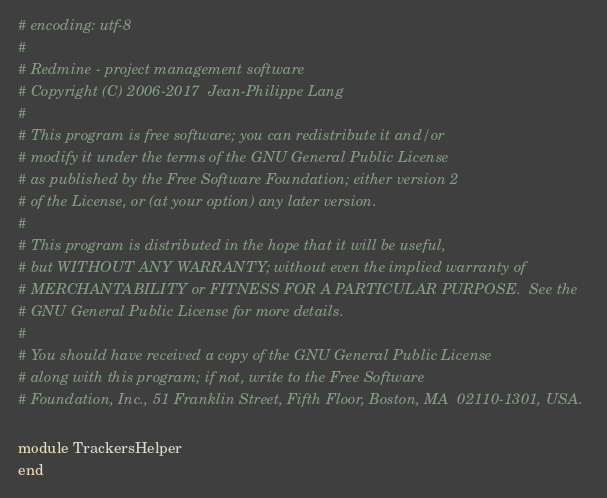<code> <loc_0><loc_0><loc_500><loc_500><_Ruby_># encoding: utf-8
#
# Redmine - project management software
# Copyright (C) 2006-2017  Jean-Philippe Lang
#
# This program is free software; you can redistribute it and/or
# modify it under the terms of the GNU General Public License
# as published by the Free Software Foundation; either version 2
# of the License, or (at your option) any later version.
#
# This program is distributed in the hope that it will be useful,
# but WITHOUT ANY WARRANTY; without even the implied warranty of
# MERCHANTABILITY or FITNESS FOR A PARTICULAR PURPOSE.  See the
# GNU General Public License for more details.
#
# You should have received a copy of the GNU General Public License
# along with this program; if not, write to the Free Software
# Foundation, Inc., 51 Franklin Street, Fifth Floor, Boston, MA  02110-1301, USA.

module TrackersHelper
end
</code> 